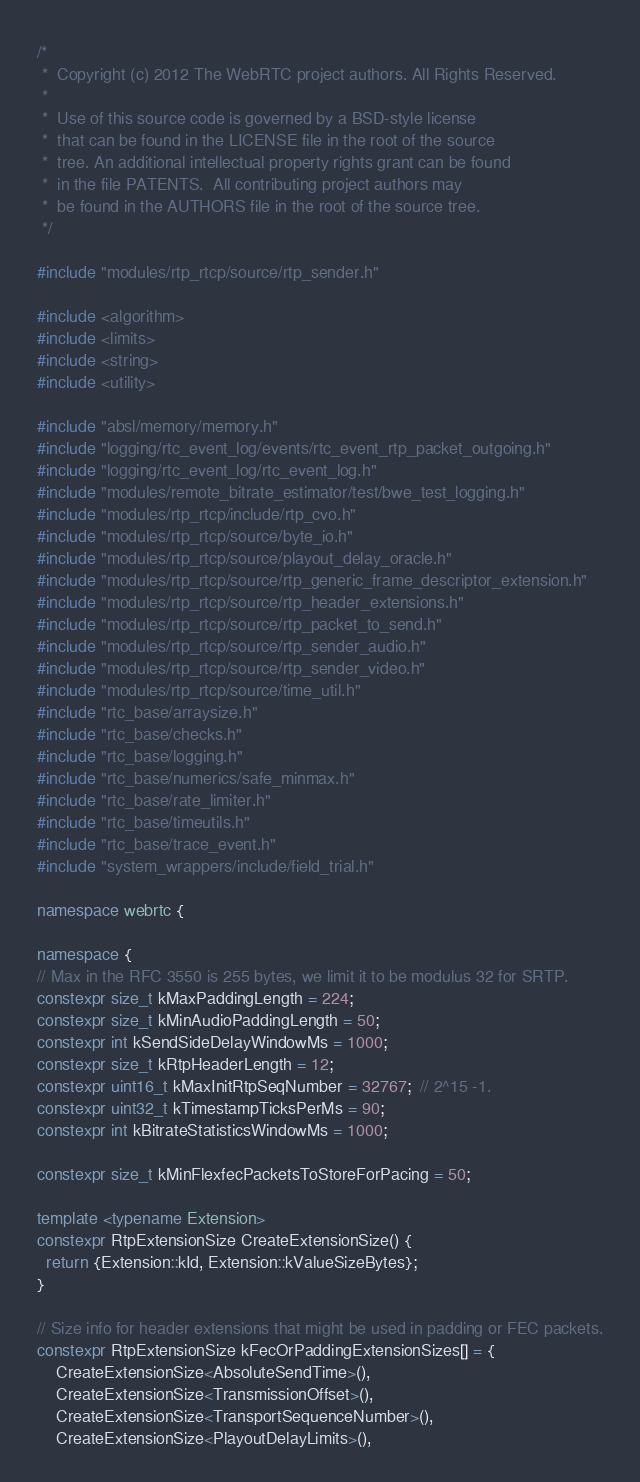<code> <loc_0><loc_0><loc_500><loc_500><_C++_>/*
 *  Copyright (c) 2012 The WebRTC project authors. All Rights Reserved.
 *
 *  Use of this source code is governed by a BSD-style license
 *  that can be found in the LICENSE file in the root of the source
 *  tree. An additional intellectual property rights grant can be found
 *  in the file PATENTS.  All contributing project authors may
 *  be found in the AUTHORS file in the root of the source tree.
 */

#include "modules/rtp_rtcp/source/rtp_sender.h"

#include <algorithm>
#include <limits>
#include <string>
#include <utility>

#include "absl/memory/memory.h"
#include "logging/rtc_event_log/events/rtc_event_rtp_packet_outgoing.h"
#include "logging/rtc_event_log/rtc_event_log.h"
#include "modules/remote_bitrate_estimator/test/bwe_test_logging.h"
#include "modules/rtp_rtcp/include/rtp_cvo.h"
#include "modules/rtp_rtcp/source/byte_io.h"
#include "modules/rtp_rtcp/source/playout_delay_oracle.h"
#include "modules/rtp_rtcp/source/rtp_generic_frame_descriptor_extension.h"
#include "modules/rtp_rtcp/source/rtp_header_extensions.h"
#include "modules/rtp_rtcp/source/rtp_packet_to_send.h"
#include "modules/rtp_rtcp/source/rtp_sender_audio.h"
#include "modules/rtp_rtcp/source/rtp_sender_video.h"
#include "modules/rtp_rtcp/source/time_util.h"
#include "rtc_base/arraysize.h"
#include "rtc_base/checks.h"
#include "rtc_base/logging.h"
#include "rtc_base/numerics/safe_minmax.h"
#include "rtc_base/rate_limiter.h"
#include "rtc_base/timeutils.h"
#include "rtc_base/trace_event.h"
#include "system_wrappers/include/field_trial.h"

namespace webrtc {

namespace {
// Max in the RFC 3550 is 255 bytes, we limit it to be modulus 32 for SRTP.
constexpr size_t kMaxPaddingLength = 224;
constexpr size_t kMinAudioPaddingLength = 50;
constexpr int kSendSideDelayWindowMs = 1000;
constexpr size_t kRtpHeaderLength = 12;
constexpr uint16_t kMaxInitRtpSeqNumber = 32767;  // 2^15 -1.
constexpr uint32_t kTimestampTicksPerMs = 90;
constexpr int kBitrateStatisticsWindowMs = 1000;

constexpr size_t kMinFlexfecPacketsToStoreForPacing = 50;

template <typename Extension>
constexpr RtpExtensionSize CreateExtensionSize() {
  return {Extension::kId, Extension::kValueSizeBytes};
}

// Size info for header extensions that might be used in padding or FEC packets.
constexpr RtpExtensionSize kFecOrPaddingExtensionSizes[] = {
    CreateExtensionSize<AbsoluteSendTime>(),
    CreateExtensionSize<TransmissionOffset>(),
    CreateExtensionSize<TransportSequenceNumber>(),
    CreateExtensionSize<PlayoutDelayLimits>(),</code> 